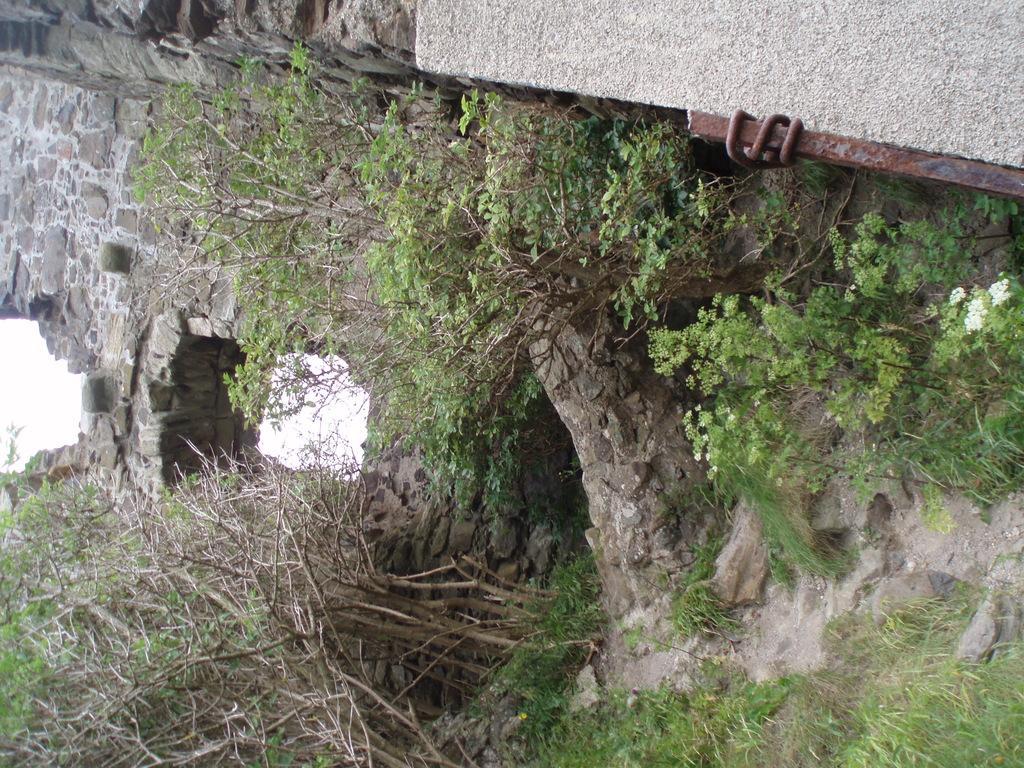Can you describe this image briefly? In this image there is a stone wall in the middle. There are trees around it. At the bottom there is a path on which there are stones and sand. On the right side bottom there is an iron pole. 